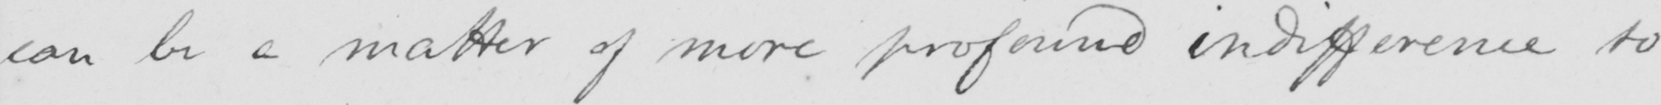What does this handwritten line say? can be a matter of more profound indifference to 